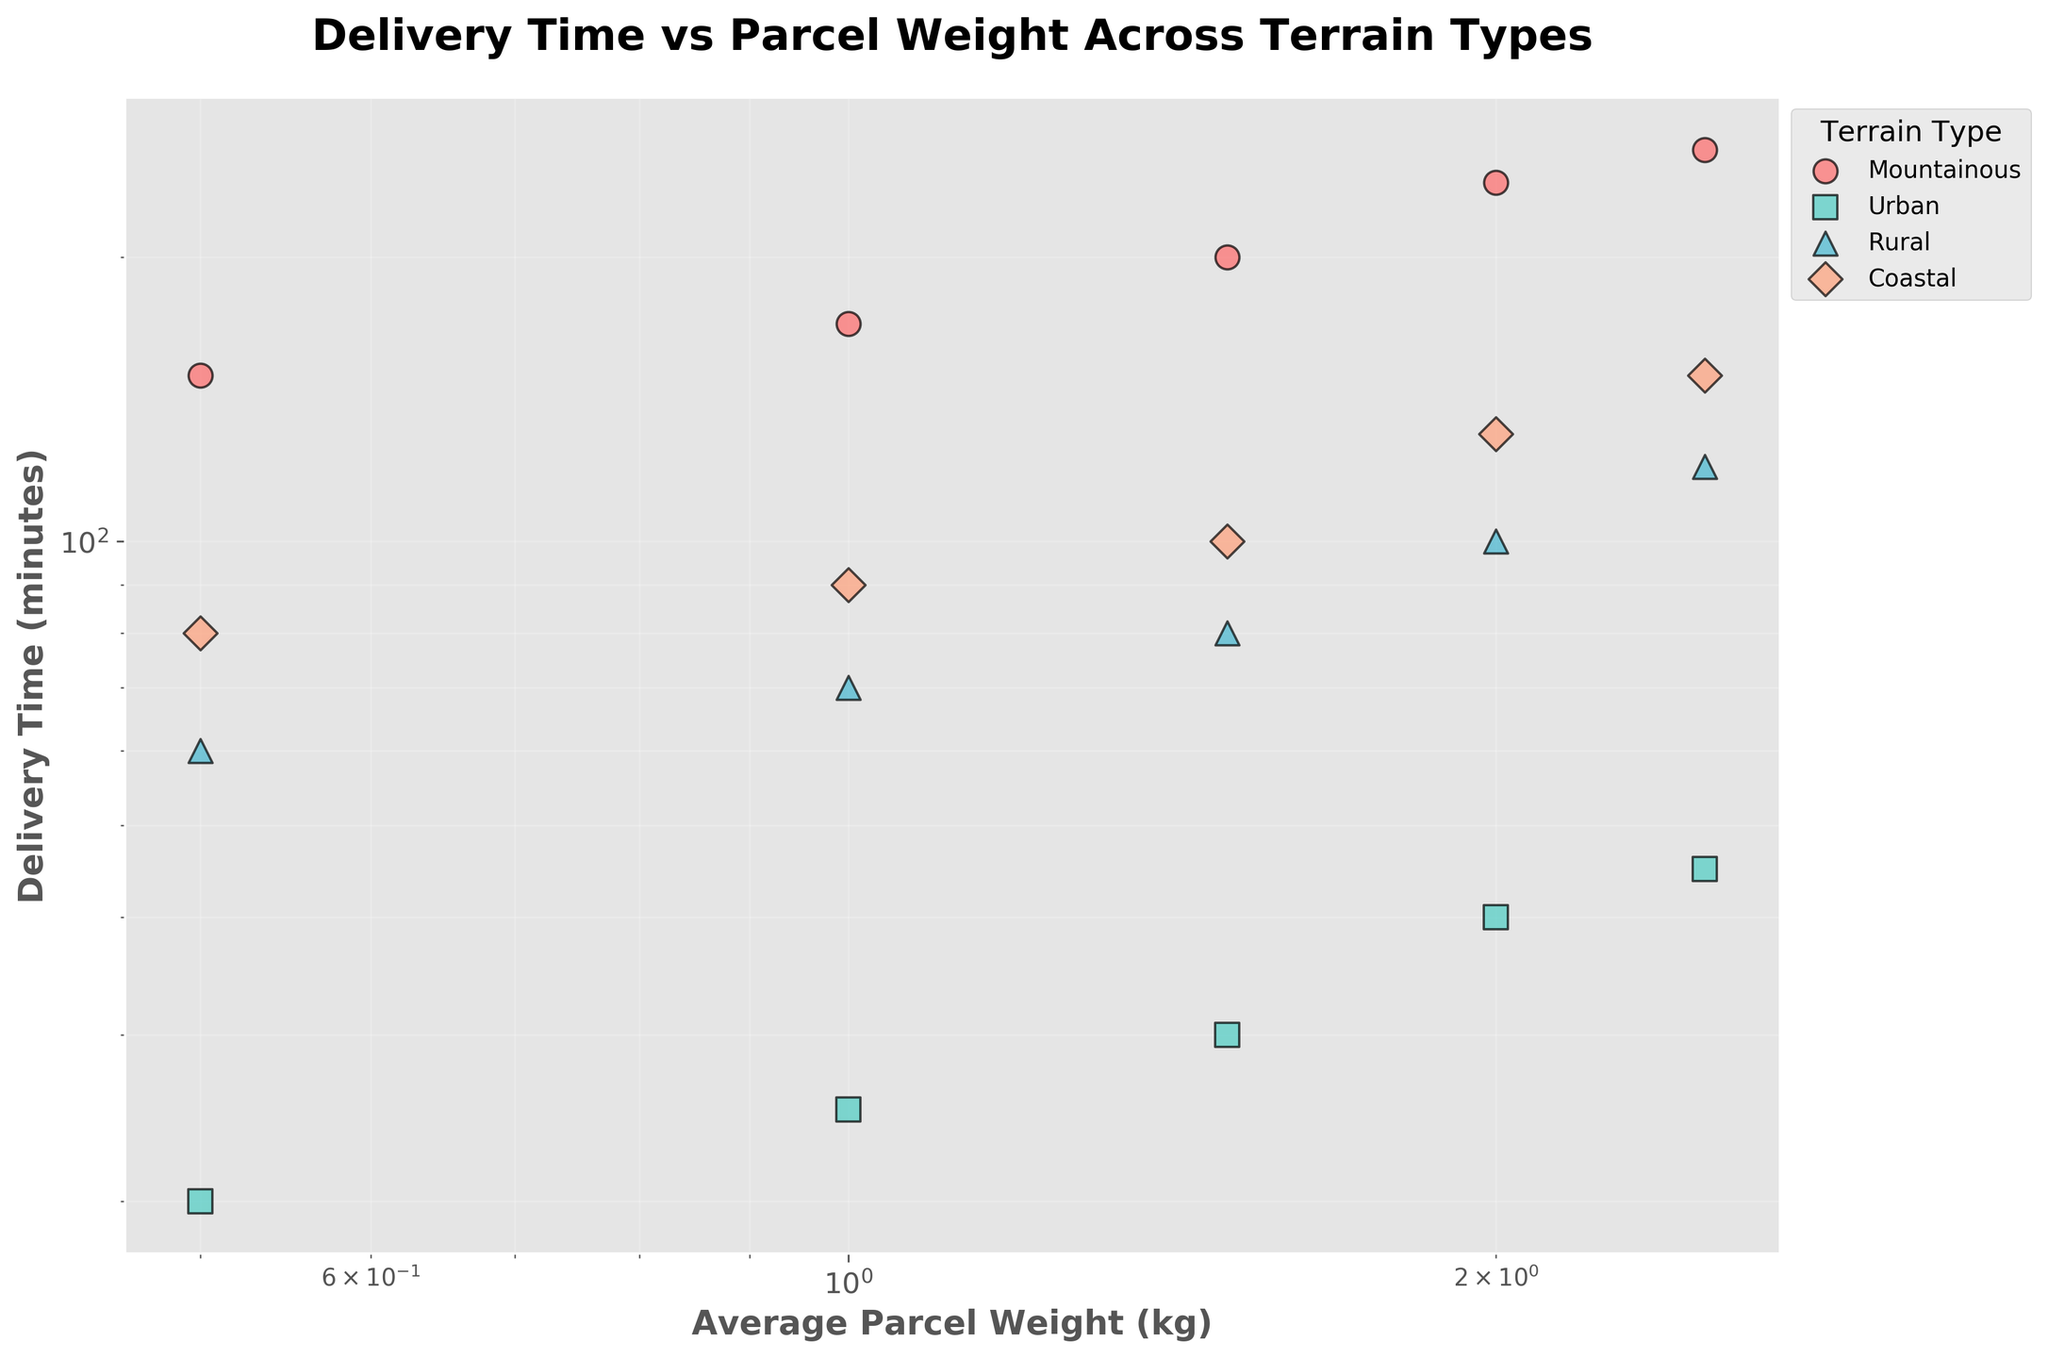How many different terrain types are represented in the plot? By looking at the legend in the plot, we can see there are four different terrain types represented: Mountainous, Urban, Rural, and Coastal.
Answer: 4 What is the title of the plot? The title is given at the top of the plot and reads "Delivery Time vs Parcel Weight Across Terrain Types".
Answer: Delivery Time vs Parcel Weight Across Terrain Types What's the general trend between parcel weight and delivery time across all terrain types? Observing the plot, we see that as the average parcel weight increases, the delivery time also generally increases for all terrain types.
Answer: As weight increases, time increases Which terrain type generally has the shortest delivery times for the same average parcel weight? Comparing the groups, the Urban data points consistently have the shortest delivery times for corresponding average parcel weights.
Answer: Urban For a parcel weighing 1 kg, which terrain type has the longest delivery time, and what is that time? For parcels weighing 1 kg, looking at the y-axis values, the Mountainous terrain has the longest delivery time, which is 170 minutes.
Answer: Mountainous, 170 minutes What pattern can be observed in the relationship between delivery time and average parcel weight on a log-log scale? On a log-log scale, a linear pattern typically indicates a power-law relationship. In this case, delivery time increases at a higher rate than parcel weight for each terrain type.
Answer: Power-law relationship Which terrain type shows the steepest increase in delivery time as parcel weight increases? Looking at the slope on the log-log scale, Mountainous terrain appears to have the steepest increase in delivery time with increasing parcel weight.
Answer: Mountainous What is the approximate delivery time for a 2.0 kg parcel in Coastal terrain? Finding the point corresponding to 2.0 kg on the x-axis and tracking it to the Coastal terrain, the delivery time is approximately 130 minutes.
Answer: 130 minutes How do delivery times compare between Rural and Coastal terrains for a parcel weighing 2.5 kg? By looking at the corresponding data points, for a 2.5 kg parcel, the delivery time in Rural terrain is 120 minutes whereas in Coastal terrain it is 150 minutes, with Coastal being longer.
Answer: Coastal is longer by 30 minutes 